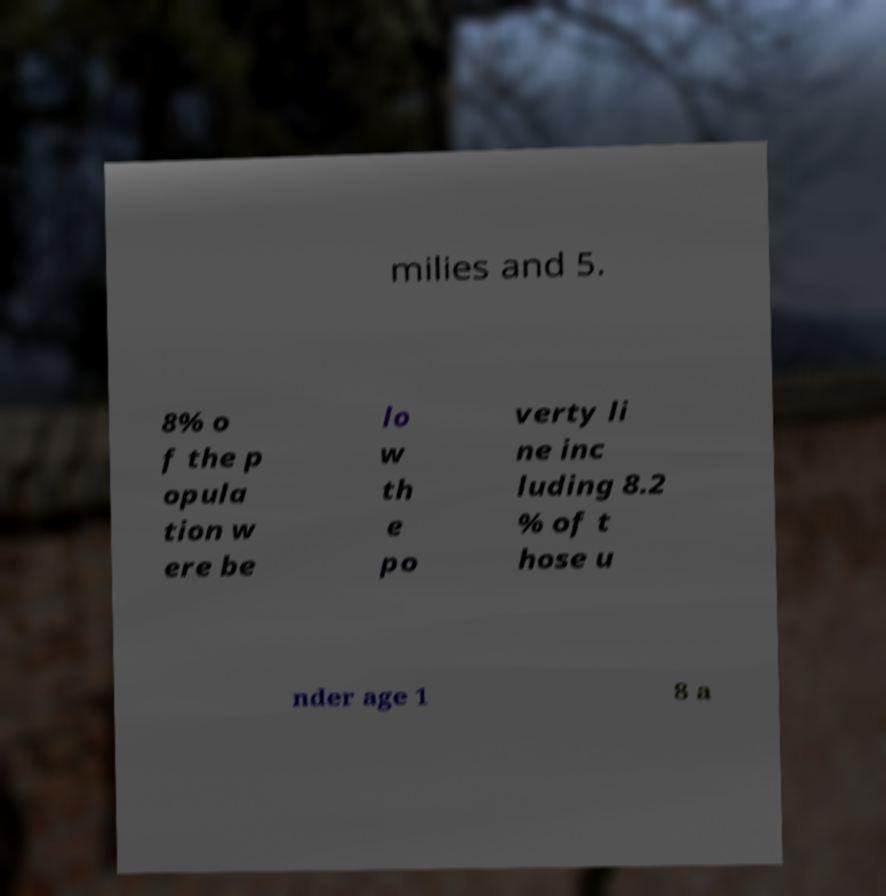I need the written content from this picture converted into text. Can you do that? milies and 5. 8% o f the p opula tion w ere be lo w th e po verty li ne inc luding 8.2 % of t hose u nder age 1 8 a 